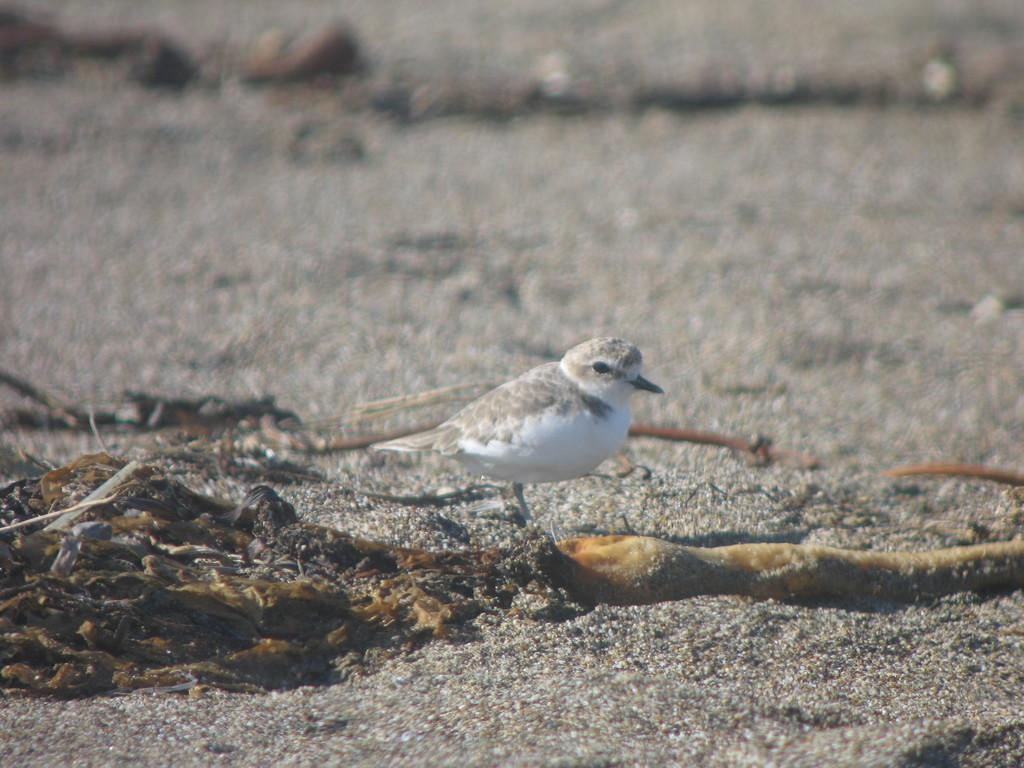What type of animal can be seen in the image? There is a bird in the image. What else is present on the ground in the image? There are objects on the ground in the image. Can you describe the background of the image? The background of the image is blurry. What type of cloud can be seen in the image? There is no cloud present in the image; the background is blurry. What type of map is visible in the image? There is no map present in the image; it features a bird and objects on the ground. 